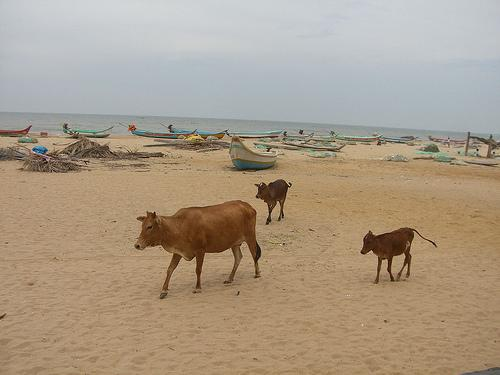Describe the weather and the time of day as seen in the image. The sky is cloudy, and the image appears to be captured during daylight. Identify the animals in the image and describe their activities. Three brown cows, including two young ones and an adult, are walking on a sandy beach with tracks in the sand, while boats are present along the shoreline. Explain what the multi-choice VQA task consists of? The multi-choice VQA task consists of answering questions about an image given a set of predefined answer choices. What is the main focus of a referential expression grounding task? The main focus of a referential expression grounding task is to identify and locate objects mentioned in textual expressions within a given image. What color is the boat located close to the center of the image? The boat close to the center of the image is blue and white. In the context of this image, describe an example of a healthy adult animal. A healthy adult cow is walking on the sandy beach with a tan nose and a clear view of its side profile. Which task involves determining relationships between sentences and visual contexts? The visual Entailment task involves determining relationships between sentences and visual contexts. Provide a concise description of this beach scene involving animals and objects. Cows are walking on a sandy beach with boats nearby, a pile of wood, and tracks in the sand beneath a cloudy sky. 